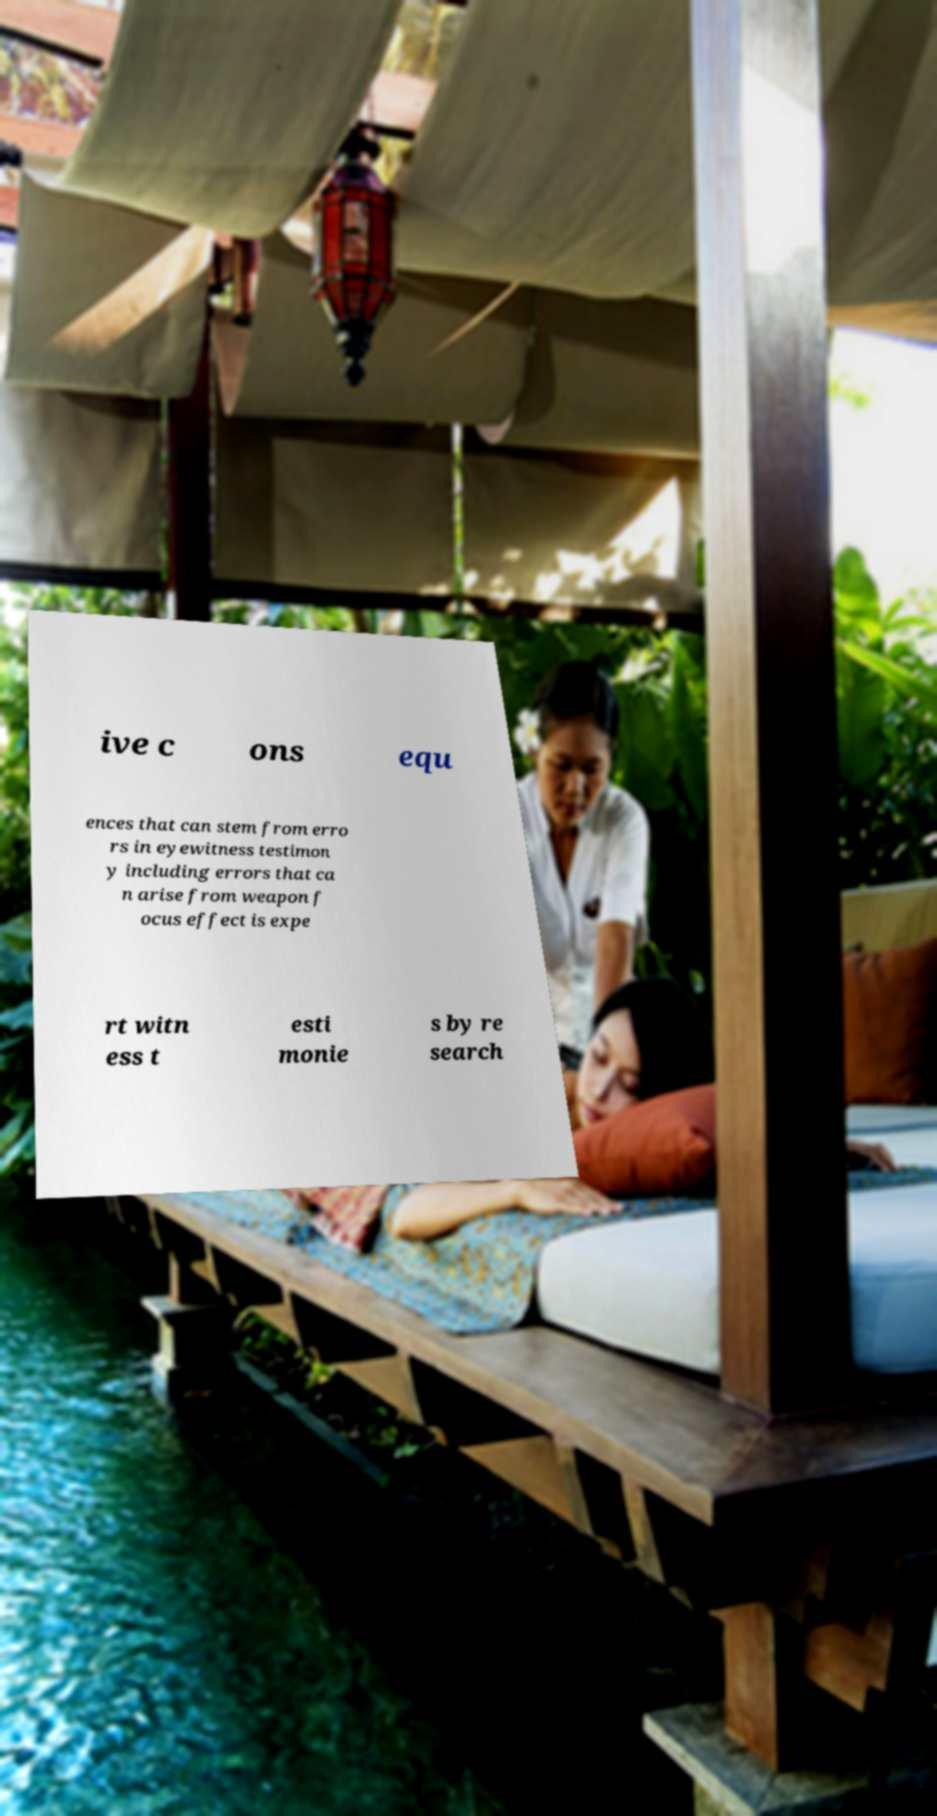There's text embedded in this image that I need extracted. Can you transcribe it verbatim? ive c ons equ ences that can stem from erro rs in eyewitness testimon y including errors that ca n arise from weapon f ocus effect is expe rt witn ess t esti monie s by re search 